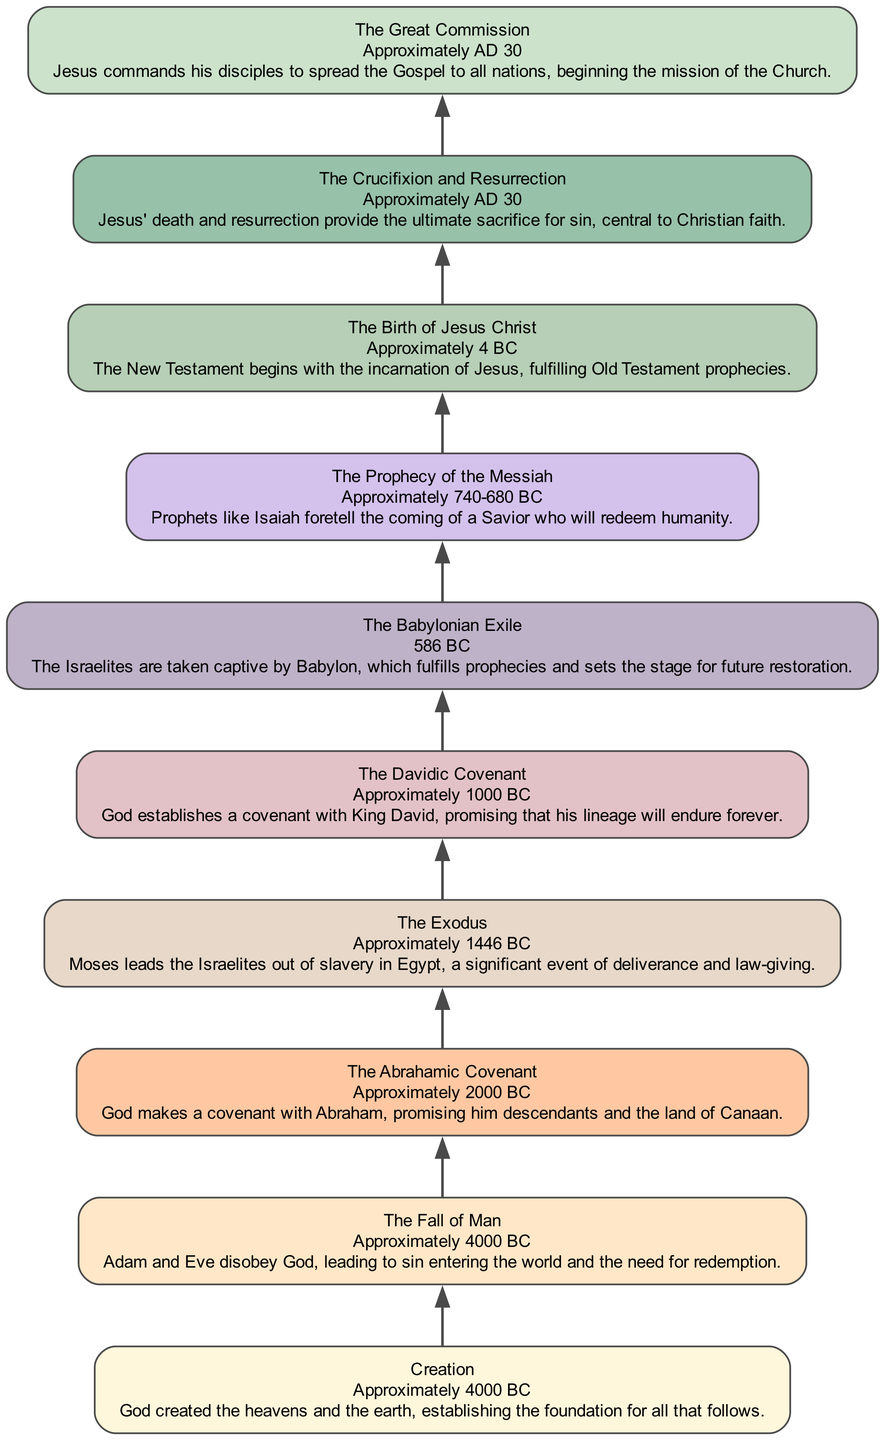What is the first event listed in the diagram? The first event at the bottom of the chart is labeled "Creation," indicating the beginning of the biblical timeline.
Answer: Creation How many significant events are depicted in the diagram? By counting all the events listed in the flow from Creation to The Great Commission, there are a total of 10 significant events included.
Answer: 10 Which event marks the beginning of the New Testament? The event titled "The Birth of Jesus Christ" is positioned just before other New Testament events, indicating it marks the beginning of the New Testament.
Answer: The Birth of Jesus Christ What event directly follows "The Davidic Covenant" in the timeline? By examining the flow, “The Babylonian Exile” immediately follows “The Davidic Covenant,” showing a sequential relationship in history.
Answer: The Babylonian Exile Which prophetic event occurs around 740 to 680 BC? The diagram identifies "The Prophecy of the Messiah," linking specific prophets to the foretelling of the Savior during that timeframe.
Answer: The Prophecy of the Messiah What is the last event listed in the flowchart? At the top of the diagram is “The Great Commission,” which concludes the flow of significant events leading to Christ and the early Church.
Answer: The Great Commission What type of covenant was made with Abraham? The event "The Abrahamic Covenant" explicitly describes the covenant made with Abraham, focusing on descendants and land promises.
Answer: The Abrahamic Covenant What relationship connects "The Crucifixion and Resurrection" to "The Great Commission"? "The Crucifixion and Resurrection" leads to "The Great Commission," as the resurrection is pivotal to the mission commanded by Jesus to His disciples.
Answer: Mission of the Church Which event caused the Israelites to seek restoration? The event labeled "The Babylonian Exile" discusses the capture of the Israelites, which sets the context for their need for future restoration.
Answer: The Babylonian Exile 